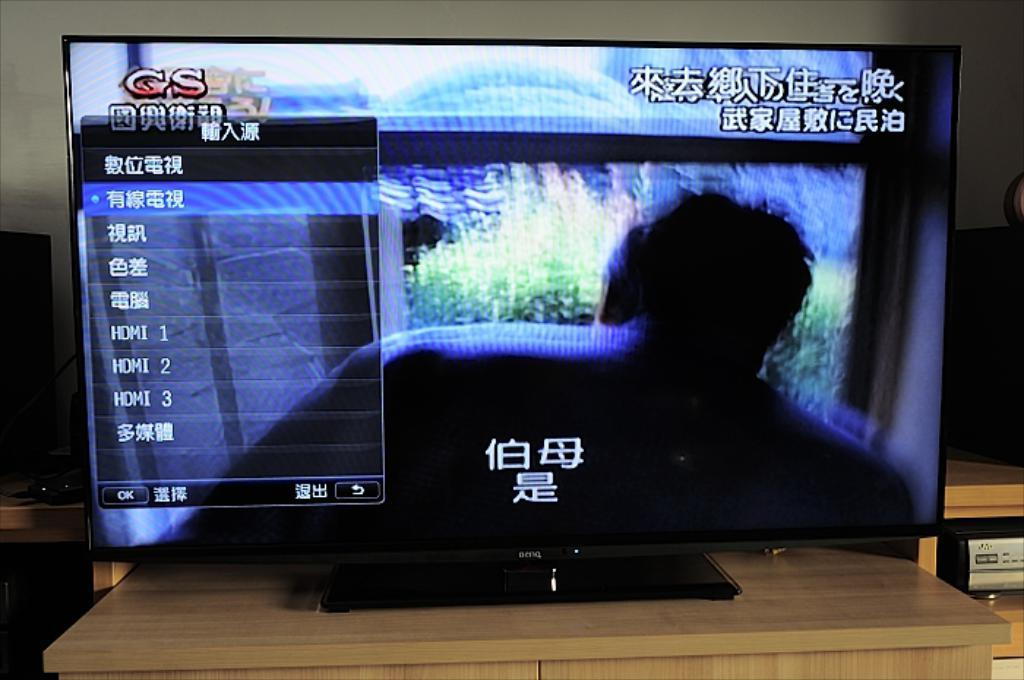<image>
Provide a brief description of the given image. A television screen that has a game on it with red CS letters in the top left. 